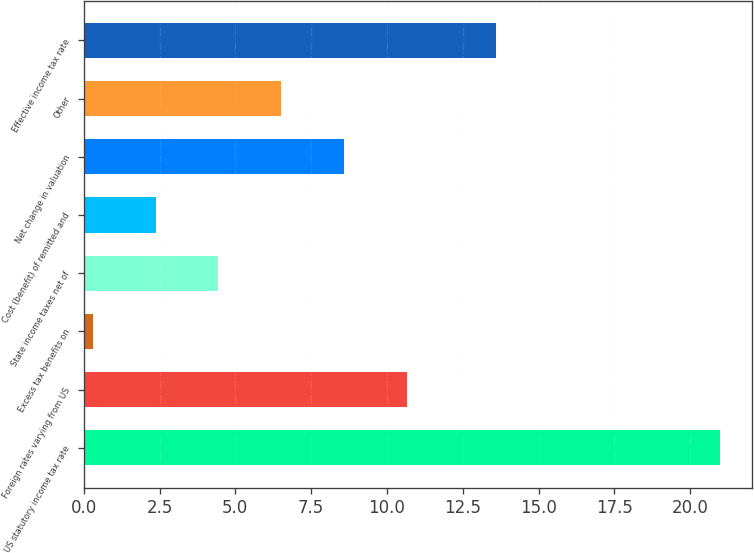Convert chart. <chart><loc_0><loc_0><loc_500><loc_500><bar_chart><fcel>US statutory income tax rate<fcel>Foreign rates varying from US<fcel>Excess tax benefits on<fcel>State income taxes net of<fcel>Cost (benefit) of remitted and<fcel>Net change in valuation<fcel>Other<fcel>Effective income tax rate<nl><fcel>21<fcel>10.65<fcel>0.3<fcel>4.44<fcel>2.37<fcel>8.58<fcel>6.51<fcel>13.6<nl></chart> 